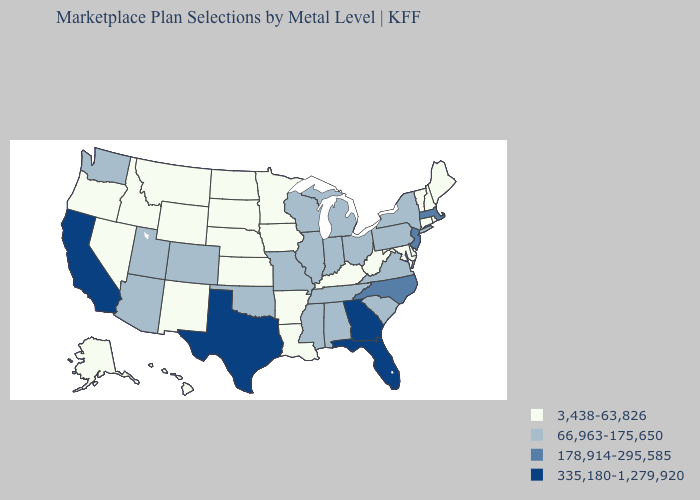Among the states that border Georgia , does Florida have the lowest value?
Short answer required. No. Which states have the lowest value in the West?
Quick response, please. Alaska, Hawaii, Idaho, Montana, Nevada, New Mexico, Oregon, Wyoming. What is the highest value in the Northeast ?
Concise answer only. 178,914-295,585. Does the map have missing data?
Answer briefly. No. What is the value of Virginia?
Write a very short answer. 66,963-175,650. Name the states that have a value in the range 3,438-63,826?
Give a very brief answer. Alaska, Arkansas, Connecticut, Delaware, Hawaii, Idaho, Iowa, Kansas, Kentucky, Louisiana, Maine, Maryland, Minnesota, Montana, Nebraska, Nevada, New Hampshire, New Mexico, North Dakota, Oregon, Rhode Island, South Dakota, Vermont, West Virginia, Wyoming. Does Arizona have the lowest value in the USA?
Short answer required. No. Does the first symbol in the legend represent the smallest category?
Write a very short answer. Yes. Name the states that have a value in the range 66,963-175,650?
Write a very short answer. Alabama, Arizona, Colorado, Illinois, Indiana, Michigan, Mississippi, Missouri, New York, Ohio, Oklahoma, Pennsylvania, South Carolina, Tennessee, Utah, Virginia, Washington, Wisconsin. What is the value of Arkansas?
Concise answer only. 3,438-63,826. Does Wyoming have the lowest value in the USA?
Be succinct. Yes. Among the states that border Kentucky , does West Virginia have the highest value?
Quick response, please. No. Name the states that have a value in the range 66,963-175,650?
Write a very short answer. Alabama, Arizona, Colorado, Illinois, Indiana, Michigan, Mississippi, Missouri, New York, Ohio, Oklahoma, Pennsylvania, South Carolina, Tennessee, Utah, Virginia, Washington, Wisconsin. What is the value of Arkansas?
Write a very short answer. 3,438-63,826. What is the highest value in states that border Kentucky?
Give a very brief answer. 66,963-175,650. 